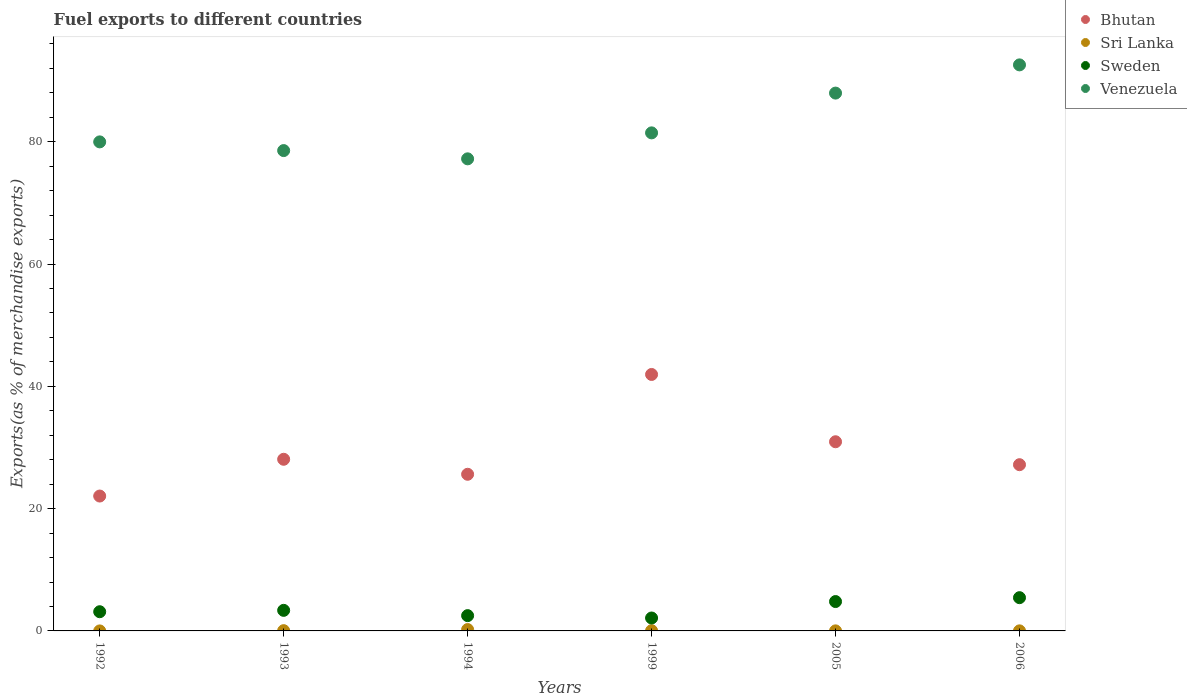Is the number of dotlines equal to the number of legend labels?
Offer a terse response. Yes. What is the percentage of exports to different countries in Sri Lanka in 1992?
Make the answer very short. 0. Across all years, what is the maximum percentage of exports to different countries in Venezuela?
Keep it short and to the point. 92.57. Across all years, what is the minimum percentage of exports to different countries in Sweden?
Your answer should be compact. 2.11. In which year was the percentage of exports to different countries in Sweden maximum?
Offer a very short reply. 2006. What is the total percentage of exports to different countries in Sweden in the graph?
Your answer should be compact. 21.36. What is the difference between the percentage of exports to different countries in Sri Lanka in 1992 and that in 2006?
Make the answer very short. -0.01. What is the difference between the percentage of exports to different countries in Sweden in 1993 and the percentage of exports to different countries in Venezuela in 2006?
Offer a very short reply. -89.21. What is the average percentage of exports to different countries in Bhutan per year?
Offer a terse response. 29.3. In the year 1992, what is the difference between the percentage of exports to different countries in Bhutan and percentage of exports to different countries in Sri Lanka?
Provide a short and direct response. 22.06. What is the ratio of the percentage of exports to different countries in Sweden in 1993 to that in 1994?
Offer a terse response. 1.35. Is the percentage of exports to different countries in Sweden in 1993 less than that in 2006?
Offer a terse response. Yes. What is the difference between the highest and the second highest percentage of exports to different countries in Sri Lanka?
Ensure brevity in your answer.  0.18. What is the difference between the highest and the lowest percentage of exports to different countries in Sri Lanka?
Your answer should be very brief. 0.22. Is the sum of the percentage of exports to different countries in Venezuela in 1992 and 2006 greater than the maximum percentage of exports to different countries in Bhutan across all years?
Offer a terse response. Yes. Is it the case that in every year, the sum of the percentage of exports to different countries in Bhutan and percentage of exports to different countries in Sri Lanka  is greater than the sum of percentage of exports to different countries in Sweden and percentage of exports to different countries in Venezuela?
Offer a very short reply. Yes. Does the percentage of exports to different countries in Sri Lanka monotonically increase over the years?
Ensure brevity in your answer.  No. How many dotlines are there?
Keep it short and to the point. 4. How many years are there in the graph?
Keep it short and to the point. 6. Are the values on the major ticks of Y-axis written in scientific E-notation?
Your answer should be very brief. No. Does the graph contain any zero values?
Make the answer very short. No. Where does the legend appear in the graph?
Your answer should be compact. Top right. How many legend labels are there?
Keep it short and to the point. 4. How are the legend labels stacked?
Your answer should be very brief. Vertical. What is the title of the graph?
Give a very brief answer. Fuel exports to different countries. What is the label or title of the Y-axis?
Provide a short and direct response. Exports(as % of merchandise exports). What is the Exports(as % of merchandise exports) of Bhutan in 1992?
Your response must be concise. 22.06. What is the Exports(as % of merchandise exports) of Sri Lanka in 1992?
Make the answer very short. 0. What is the Exports(as % of merchandise exports) in Sweden in 1992?
Make the answer very short. 3.14. What is the Exports(as % of merchandise exports) in Venezuela in 1992?
Make the answer very short. 79.98. What is the Exports(as % of merchandise exports) of Bhutan in 1993?
Offer a very short reply. 28.07. What is the Exports(as % of merchandise exports) in Sri Lanka in 1993?
Make the answer very short. 0.04. What is the Exports(as % of merchandise exports) in Sweden in 1993?
Ensure brevity in your answer.  3.36. What is the Exports(as % of merchandise exports) of Venezuela in 1993?
Provide a succinct answer. 78.56. What is the Exports(as % of merchandise exports) of Bhutan in 1994?
Your answer should be very brief. 25.62. What is the Exports(as % of merchandise exports) of Sri Lanka in 1994?
Your answer should be very brief. 0.22. What is the Exports(as % of merchandise exports) in Sweden in 1994?
Your response must be concise. 2.5. What is the Exports(as % of merchandise exports) of Venezuela in 1994?
Ensure brevity in your answer.  77.21. What is the Exports(as % of merchandise exports) in Bhutan in 1999?
Your response must be concise. 41.94. What is the Exports(as % of merchandise exports) in Sri Lanka in 1999?
Make the answer very short. 0.04. What is the Exports(as % of merchandise exports) of Sweden in 1999?
Your response must be concise. 2.11. What is the Exports(as % of merchandise exports) in Venezuela in 1999?
Give a very brief answer. 81.45. What is the Exports(as % of merchandise exports) of Bhutan in 2005?
Provide a succinct answer. 30.94. What is the Exports(as % of merchandise exports) in Sri Lanka in 2005?
Keep it short and to the point. 0.01. What is the Exports(as % of merchandise exports) in Sweden in 2005?
Ensure brevity in your answer.  4.8. What is the Exports(as % of merchandise exports) of Venezuela in 2005?
Provide a short and direct response. 87.96. What is the Exports(as % of merchandise exports) of Bhutan in 2006?
Give a very brief answer. 27.19. What is the Exports(as % of merchandise exports) of Sri Lanka in 2006?
Give a very brief answer. 0.01. What is the Exports(as % of merchandise exports) of Sweden in 2006?
Provide a succinct answer. 5.44. What is the Exports(as % of merchandise exports) of Venezuela in 2006?
Your answer should be compact. 92.57. Across all years, what is the maximum Exports(as % of merchandise exports) of Bhutan?
Your response must be concise. 41.94. Across all years, what is the maximum Exports(as % of merchandise exports) in Sri Lanka?
Give a very brief answer. 0.22. Across all years, what is the maximum Exports(as % of merchandise exports) in Sweden?
Your answer should be compact. 5.44. Across all years, what is the maximum Exports(as % of merchandise exports) in Venezuela?
Provide a succinct answer. 92.57. Across all years, what is the minimum Exports(as % of merchandise exports) in Bhutan?
Offer a very short reply. 22.06. Across all years, what is the minimum Exports(as % of merchandise exports) in Sri Lanka?
Give a very brief answer. 0. Across all years, what is the minimum Exports(as % of merchandise exports) in Sweden?
Offer a very short reply. 2.11. Across all years, what is the minimum Exports(as % of merchandise exports) of Venezuela?
Provide a short and direct response. 77.21. What is the total Exports(as % of merchandise exports) in Bhutan in the graph?
Keep it short and to the point. 175.81. What is the total Exports(as % of merchandise exports) in Sri Lanka in the graph?
Your response must be concise. 0.32. What is the total Exports(as % of merchandise exports) of Sweden in the graph?
Give a very brief answer. 21.36. What is the total Exports(as % of merchandise exports) of Venezuela in the graph?
Your answer should be compact. 497.73. What is the difference between the Exports(as % of merchandise exports) of Bhutan in 1992 and that in 1993?
Provide a succinct answer. -6.01. What is the difference between the Exports(as % of merchandise exports) in Sri Lanka in 1992 and that in 1993?
Keep it short and to the point. -0.04. What is the difference between the Exports(as % of merchandise exports) of Sweden in 1992 and that in 1993?
Offer a terse response. -0.22. What is the difference between the Exports(as % of merchandise exports) in Venezuela in 1992 and that in 1993?
Your answer should be compact. 1.42. What is the difference between the Exports(as % of merchandise exports) in Bhutan in 1992 and that in 1994?
Give a very brief answer. -3.56. What is the difference between the Exports(as % of merchandise exports) of Sri Lanka in 1992 and that in 1994?
Offer a very short reply. -0.22. What is the difference between the Exports(as % of merchandise exports) of Sweden in 1992 and that in 1994?
Offer a terse response. 0.64. What is the difference between the Exports(as % of merchandise exports) in Venezuela in 1992 and that in 1994?
Provide a short and direct response. 2.77. What is the difference between the Exports(as % of merchandise exports) of Bhutan in 1992 and that in 1999?
Ensure brevity in your answer.  -19.88. What is the difference between the Exports(as % of merchandise exports) in Sri Lanka in 1992 and that in 1999?
Offer a terse response. -0.04. What is the difference between the Exports(as % of merchandise exports) of Sweden in 1992 and that in 1999?
Your answer should be compact. 1.03. What is the difference between the Exports(as % of merchandise exports) in Venezuela in 1992 and that in 1999?
Your answer should be compact. -1.47. What is the difference between the Exports(as % of merchandise exports) in Bhutan in 1992 and that in 2005?
Keep it short and to the point. -8.88. What is the difference between the Exports(as % of merchandise exports) of Sri Lanka in 1992 and that in 2005?
Your response must be concise. -0.01. What is the difference between the Exports(as % of merchandise exports) in Sweden in 1992 and that in 2005?
Offer a very short reply. -1.66. What is the difference between the Exports(as % of merchandise exports) of Venezuela in 1992 and that in 2005?
Your response must be concise. -7.98. What is the difference between the Exports(as % of merchandise exports) in Bhutan in 1992 and that in 2006?
Your answer should be very brief. -5.13. What is the difference between the Exports(as % of merchandise exports) of Sri Lanka in 1992 and that in 2006?
Your response must be concise. -0.01. What is the difference between the Exports(as % of merchandise exports) of Sweden in 1992 and that in 2006?
Provide a succinct answer. -2.3. What is the difference between the Exports(as % of merchandise exports) of Venezuela in 1992 and that in 2006?
Keep it short and to the point. -12.59. What is the difference between the Exports(as % of merchandise exports) of Bhutan in 1993 and that in 1994?
Your answer should be compact. 2.45. What is the difference between the Exports(as % of merchandise exports) of Sri Lanka in 1993 and that in 1994?
Keep it short and to the point. -0.18. What is the difference between the Exports(as % of merchandise exports) in Sweden in 1993 and that in 1994?
Offer a terse response. 0.86. What is the difference between the Exports(as % of merchandise exports) of Venezuela in 1993 and that in 1994?
Make the answer very short. 1.35. What is the difference between the Exports(as % of merchandise exports) in Bhutan in 1993 and that in 1999?
Give a very brief answer. -13.87. What is the difference between the Exports(as % of merchandise exports) in Sri Lanka in 1993 and that in 1999?
Offer a very short reply. 0. What is the difference between the Exports(as % of merchandise exports) in Sweden in 1993 and that in 1999?
Your answer should be compact. 1.25. What is the difference between the Exports(as % of merchandise exports) of Venezuela in 1993 and that in 1999?
Ensure brevity in your answer.  -2.9. What is the difference between the Exports(as % of merchandise exports) in Bhutan in 1993 and that in 2005?
Your response must be concise. -2.87. What is the difference between the Exports(as % of merchandise exports) of Sri Lanka in 1993 and that in 2005?
Your answer should be very brief. 0.03. What is the difference between the Exports(as % of merchandise exports) in Sweden in 1993 and that in 2005?
Make the answer very short. -1.44. What is the difference between the Exports(as % of merchandise exports) of Venezuela in 1993 and that in 2005?
Offer a terse response. -9.4. What is the difference between the Exports(as % of merchandise exports) of Bhutan in 1993 and that in 2006?
Keep it short and to the point. 0.89. What is the difference between the Exports(as % of merchandise exports) in Sri Lanka in 1993 and that in 2006?
Make the answer very short. 0.03. What is the difference between the Exports(as % of merchandise exports) in Sweden in 1993 and that in 2006?
Provide a short and direct response. -2.07. What is the difference between the Exports(as % of merchandise exports) in Venezuela in 1993 and that in 2006?
Keep it short and to the point. -14.02. What is the difference between the Exports(as % of merchandise exports) of Bhutan in 1994 and that in 1999?
Give a very brief answer. -16.32. What is the difference between the Exports(as % of merchandise exports) in Sri Lanka in 1994 and that in 1999?
Offer a terse response. 0.18. What is the difference between the Exports(as % of merchandise exports) of Sweden in 1994 and that in 1999?
Your response must be concise. 0.39. What is the difference between the Exports(as % of merchandise exports) in Venezuela in 1994 and that in 1999?
Offer a very short reply. -4.25. What is the difference between the Exports(as % of merchandise exports) of Bhutan in 1994 and that in 2005?
Your answer should be very brief. -5.32. What is the difference between the Exports(as % of merchandise exports) of Sri Lanka in 1994 and that in 2005?
Your answer should be compact. 0.21. What is the difference between the Exports(as % of merchandise exports) in Sweden in 1994 and that in 2005?
Ensure brevity in your answer.  -2.3. What is the difference between the Exports(as % of merchandise exports) of Venezuela in 1994 and that in 2005?
Keep it short and to the point. -10.75. What is the difference between the Exports(as % of merchandise exports) of Bhutan in 1994 and that in 2006?
Ensure brevity in your answer.  -1.57. What is the difference between the Exports(as % of merchandise exports) of Sri Lanka in 1994 and that in 2006?
Your answer should be very brief. 0.21. What is the difference between the Exports(as % of merchandise exports) of Sweden in 1994 and that in 2006?
Ensure brevity in your answer.  -2.94. What is the difference between the Exports(as % of merchandise exports) in Venezuela in 1994 and that in 2006?
Offer a terse response. -15.37. What is the difference between the Exports(as % of merchandise exports) in Bhutan in 1999 and that in 2005?
Offer a terse response. 11. What is the difference between the Exports(as % of merchandise exports) of Sri Lanka in 1999 and that in 2005?
Your answer should be very brief. 0.03. What is the difference between the Exports(as % of merchandise exports) of Sweden in 1999 and that in 2005?
Give a very brief answer. -2.69. What is the difference between the Exports(as % of merchandise exports) in Venezuela in 1999 and that in 2005?
Your answer should be compact. -6.5. What is the difference between the Exports(as % of merchandise exports) in Bhutan in 1999 and that in 2006?
Your response must be concise. 14.76. What is the difference between the Exports(as % of merchandise exports) of Sri Lanka in 1999 and that in 2006?
Your answer should be very brief. 0.03. What is the difference between the Exports(as % of merchandise exports) of Sweden in 1999 and that in 2006?
Ensure brevity in your answer.  -3.33. What is the difference between the Exports(as % of merchandise exports) in Venezuela in 1999 and that in 2006?
Your response must be concise. -11.12. What is the difference between the Exports(as % of merchandise exports) in Bhutan in 2005 and that in 2006?
Provide a succinct answer. 3.75. What is the difference between the Exports(as % of merchandise exports) in Sri Lanka in 2005 and that in 2006?
Offer a very short reply. -0. What is the difference between the Exports(as % of merchandise exports) of Sweden in 2005 and that in 2006?
Provide a short and direct response. -0.63. What is the difference between the Exports(as % of merchandise exports) of Venezuela in 2005 and that in 2006?
Ensure brevity in your answer.  -4.62. What is the difference between the Exports(as % of merchandise exports) of Bhutan in 1992 and the Exports(as % of merchandise exports) of Sri Lanka in 1993?
Keep it short and to the point. 22.02. What is the difference between the Exports(as % of merchandise exports) of Bhutan in 1992 and the Exports(as % of merchandise exports) of Sweden in 1993?
Provide a short and direct response. 18.7. What is the difference between the Exports(as % of merchandise exports) in Bhutan in 1992 and the Exports(as % of merchandise exports) in Venezuela in 1993?
Your answer should be compact. -56.5. What is the difference between the Exports(as % of merchandise exports) in Sri Lanka in 1992 and the Exports(as % of merchandise exports) in Sweden in 1993?
Give a very brief answer. -3.36. What is the difference between the Exports(as % of merchandise exports) in Sri Lanka in 1992 and the Exports(as % of merchandise exports) in Venezuela in 1993?
Make the answer very short. -78.56. What is the difference between the Exports(as % of merchandise exports) in Sweden in 1992 and the Exports(as % of merchandise exports) in Venezuela in 1993?
Offer a very short reply. -75.42. What is the difference between the Exports(as % of merchandise exports) in Bhutan in 1992 and the Exports(as % of merchandise exports) in Sri Lanka in 1994?
Your response must be concise. 21.84. What is the difference between the Exports(as % of merchandise exports) in Bhutan in 1992 and the Exports(as % of merchandise exports) in Sweden in 1994?
Provide a succinct answer. 19.56. What is the difference between the Exports(as % of merchandise exports) of Bhutan in 1992 and the Exports(as % of merchandise exports) of Venezuela in 1994?
Offer a terse response. -55.15. What is the difference between the Exports(as % of merchandise exports) in Sri Lanka in 1992 and the Exports(as % of merchandise exports) in Sweden in 1994?
Your answer should be compact. -2.5. What is the difference between the Exports(as % of merchandise exports) in Sri Lanka in 1992 and the Exports(as % of merchandise exports) in Venezuela in 1994?
Provide a short and direct response. -77.21. What is the difference between the Exports(as % of merchandise exports) of Sweden in 1992 and the Exports(as % of merchandise exports) of Venezuela in 1994?
Your response must be concise. -74.07. What is the difference between the Exports(as % of merchandise exports) of Bhutan in 1992 and the Exports(as % of merchandise exports) of Sri Lanka in 1999?
Offer a terse response. 22.02. What is the difference between the Exports(as % of merchandise exports) in Bhutan in 1992 and the Exports(as % of merchandise exports) in Sweden in 1999?
Give a very brief answer. 19.95. What is the difference between the Exports(as % of merchandise exports) in Bhutan in 1992 and the Exports(as % of merchandise exports) in Venezuela in 1999?
Provide a short and direct response. -59.39. What is the difference between the Exports(as % of merchandise exports) of Sri Lanka in 1992 and the Exports(as % of merchandise exports) of Sweden in 1999?
Provide a succinct answer. -2.11. What is the difference between the Exports(as % of merchandise exports) in Sri Lanka in 1992 and the Exports(as % of merchandise exports) in Venezuela in 1999?
Make the answer very short. -81.45. What is the difference between the Exports(as % of merchandise exports) of Sweden in 1992 and the Exports(as % of merchandise exports) of Venezuela in 1999?
Provide a succinct answer. -78.31. What is the difference between the Exports(as % of merchandise exports) in Bhutan in 1992 and the Exports(as % of merchandise exports) in Sri Lanka in 2005?
Your response must be concise. 22.05. What is the difference between the Exports(as % of merchandise exports) of Bhutan in 1992 and the Exports(as % of merchandise exports) of Sweden in 2005?
Give a very brief answer. 17.26. What is the difference between the Exports(as % of merchandise exports) of Bhutan in 1992 and the Exports(as % of merchandise exports) of Venezuela in 2005?
Provide a short and direct response. -65.9. What is the difference between the Exports(as % of merchandise exports) of Sri Lanka in 1992 and the Exports(as % of merchandise exports) of Sweden in 2005?
Give a very brief answer. -4.8. What is the difference between the Exports(as % of merchandise exports) of Sri Lanka in 1992 and the Exports(as % of merchandise exports) of Venezuela in 2005?
Ensure brevity in your answer.  -87.96. What is the difference between the Exports(as % of merchandise exports) in Sweden in 1992 and the Exports(as % of merchandise exports) in Venezuela in 2005?
Offer a terse response. -84.82. What is the difference between the Exports(as % of merchandise exports) in Bhutan in 1992 and the Exports(as % of merchandise exports) in Sri Lanka in 2006?
Your answer should be very brief. 22.05. What is the difference between the Exports(as % of merchandise exports) in Bhutan in 1992 and the Exports(as % of merchandise exports) in Sweden in 2006?
Ensure brevity in your answer.  16.62. What is the difference between the Exports(as % of merchandise exports) of Bhutan in 1992 and the Exports(as % of merchandise exports) of Venezuela in 2006?
Provide a succinct answer. -70.51. What is the difference between the Exports(as % of merchandise exports) in Sri Lanka in 1992 and the Exports(as % of merchandise exports) in Sweden in 2006?
Provide a succinct answer. -5.44. What is the difference between the Exports(as % of merchandise exports) of Sri Lanka in 1992 and the Exports(as % of merchandise exports) of Venezuela in 2006?
Keep it short and to the point. -92.57. What is the difference between the Exports(as % of merchandise exports) in Sweden in 1992 and the Exports(as % of merchandise exports) in Venezuela in 2006?
Make the answer very short. -89.43. What is the difference between the Exports(as % of merchandise exports) in Bhutan in 1993 and the Exports(as % of merchandise exports) in Sri Lanka in 1994?
Your answer should be very brief. 27.85. What is the difference between the Exports(as % of merchandise exports) of Bhutan in 1993 and the Exports(as % of merchandise exports) of Sweden in 1994?
Offer a terse response. 25.57. What is the difference between the Exports(as % of merchandise exports) of Bhutan in 1993 and the Exports(as % of merchandise exports) of Venezuela in 1994?
Your answer should be compact. -49.14. What is the difference between the Exports(as % of merchandise exports) of Sri Lanka in 1993 and the Exports(as % of merchandise exports) of Sweden in 1994?
Provide a succinct answer. -2.46. What is the difference between the Exports(as % of merchandise exports) of Sri Lanka in 1993 and the Exports(as % of merchandise exports) of Venezuela in 1994?
Provide a succinct answer. -77.16. What is the difference between the Exports(as % of merchandise exports) of Sweden in 1993 and the Exports(as % of merchandise exports) of Venezuela in 1994?
Give a very brief answer. -73.84. What is the difference between the Exports(as % of merchandise exports) of Bhutan in 1993 and the Exports(as % of merchandise exports) of Sri Lanka in 1999?
Provide a succinct answer. 28.03. What is the difference between the Exports(as % of merchandise exports) of Bhutan in 1993 and the Exports(as % of merchandise exports) of Sweden in 1999?
Make the answer very short. 25.96. What is the difference between the Exports(as % of merchandise exports) of Bhutan in 1993 and the Exports(as % of merchandise exports) of Venezuela in 1999?
Provide a short and direct response. -53.38. What is the difference between the Exports(as % of merchandise exports) of Sri Lanka in 1993 and the Exports(as % of merchandise exports) of Sweden in 1999?
Provide a succinct answer. -2.07. What is the difference between the Exports(as % of merchandise exports) of Sri Lanka in 1993 and the Exports(as % of merchandise exports) of Venezuela in 1999?
Your answer should be compact. -81.41. What is the difference between the Exports(as % of merchandise exports) of Sweden in 1993 and the Exports(as % of merchandise exports) of Venezuela in 1999?
Make the answer very short. -78.09. What is the difference between the Exports(as % of merchandise exports) in Bhutan in 1993 and the Exports(as % of merchandise exports) in Sri Lanka in 2005?
Make the answer very short. 28.06. What is the difference between the Exports(as % of merchandise exports) of Bhutan in 1993 and the Exports(as % of merchandise exports) of Sweden in 2005?
Your answer should be very brief. 23.27. What is the difference between the Exports(as % of merchandise exports) of Bhutan in 1993 and the Exports(as % of merchandise exports) of Venezuela in 2005?
Ensure brevity in your answer.  -59.89. What is the difference between the Exports(as % of merchandise exports) of Sri Lanka in 1993 and the Exports(as % of merchandise exports) of Sweden in 2005?
Offer a terse response. -4.76. What is the difference between the Exports(as % of merchandise exports) in Sri Lanka in 1993 and the Exports(as % of merchandise exports) in Venezuela in 2005?
Make the answer very short. -87.92. What is the difference between the Exports(as % of merchandise exports) in Sweden in 1993 and the Exports(as % of merchandise exports) in Venezuela in 2005?
Offer a very short reply. -84.59. What is the difference between the Exports(as % of merchandise exports) of Bhutan in 1993 and the Exports(as % of merchandise exports) of Sri Lanka in 2006?
Offer a very short reply. 28.06. What is the difference between the Exports(as % of merchandise exports) in Bhutan in 1993 and the Exports(as % of merchandise exports) in Sweden in 2006?
Give a very brief answer. 22.63. What is the difference between the Exports(as % of merchandise exports) of Bhutan in 1993 and the Exports(as % of merchandise exports) of Venezuela in 2006?
Your answer should be compact. -64.5. What is the difference between the Exports(as % of merchandise exports) in Sri Lanka in 1993 and the Exports(as % of merchandise exports) in Sweden in 2006?
Your answer should be very brief. -5.4. What is the difference between the Exports(as % of merchandise exports) in Sri Lanka in 1993 and the Exports(as % of merchandise exports) in Venezuela in 2006?
Keep it short and to the point. -92.53. What is the difference between the Exports(as % of merchandise exports) in Sweden in 1993 and the Exports(as % of merchandise exports) in Venezuela in 2006?
Offer a terse response. -89.21. What is the difference between the Exports(as % of merchandise exports) of Bhutan in 1994 and the Exports(as % of merchandise exports) of Sri Lanka in 1999?
Provide a succinct answer. 25.58. What is the difference between the Exports(as % of merchandise exports) in Bhutan in 1994 and the Exports(as % of merchandise exports) in Sweden in 1999?
Your answer should be compact. 23.51. What is the difference between the Exports(as % of merchandise exports) in Bhutan in 1994 and the Exports(as % of merchandise exports) in Venezuela in 1999?
Keep it short and to the point. -55.84. What is the difference between the Exports(as % of merchandise exports) of Sri Lanka in 1994 and the Exports(as % of merchandise exports) of Sweden in 1999?
Your answer should be very brief. -1.89. What is the difference between the Exports(as % of merchandise exports) of Sri Lanka in 1994 and the Exports(as % of merchandise exports) of Venezuela in 1999?
Keep it short and to the point. -81.23. What is the difference between the Exports(as % of merchandise exports) in Sweden in 1994 and the Exports(as % of merchandise exports) in Venezuela in 1999?
Your answer should be compact. -78.95. What is the difference between the Exports(as % of merchandise exports) of Bhutan in 1994 and the Exports(as % of merchandise exports) of Sri Lanka in 2005?
Offer a very short reply. 25.61. What is the difference between the Exports(as % of merchandise exports) of Bhutan in 1994 and the Exports(as % of merchandise exports) of Sweden in 2005?
Give a very brief answer. 20.81. What is the difference between the Exports(as % of merchandise exports) of Bhutan in 1994 and the Exports(as % of merchandise exports) of Venezuela in 2005?
Offer a very short reply. -62.34. What is the difference between the Exports(as % of merchandise exports) of Sri Lanka in 1994 and the Exports(as % of merchandise exports) of Sweden in 2005?
Provide a succinct answer. -4.58. What is the difference between the Exports(as % of merchandise exports) of Sri Lanka in 1994 and the Exports(as % of merchandise exports) of Venezuela in 2005?
Keep it short and to the point. -87.73. What is the difference between the Exports(as % of merchandise exports) in Sweden in 1994 and the Exports(as % of merchandise exports) in Venezuela in 2005?
Your answer should be compact. -85.46. What is the difference between the Exports(as % of merchandise exports) in Bhutan in 1994 and the Exports(as % of merchandise exports) in Sri Lanka in 2006?
Ensure brevity in your answer.  25.61. What is the difference between the Exports(as % of merchandise exports) in Bhutan in 1994 and the Exports(as % of merchandise exports) in Sweden in 2006?
Offer a terse response. 20.18. What is the difference between the Exports(as % of merchandise exports) in Bhutan in 1994 and the Exports(as % of merchandise exports) in Venezuela in 2006?
Offer a terse response. -66.95. What is the difference between the Exports(as % of merchandise exports) in Sri Lanka in 1994 and the Exports(as % of merchandise exports) in Sweden in 2006?
Offer a terse response. -5.21. What is the difference between the Exports(as % of merchandise exports) in Sri Lanka in 1994 and the Exports(as % of merchandise exports) in Venezuela in 2006?
Your answer should be very brief. -92.35. What is the difference between the Exports(as % of merchandise exports) in Sweden in 1994 and the Exports(as % of merchandise exports) in Venezuela in 2006?
Make the answer very short. -90.07. What is the difference between the Exports(as % of merchandise exports) of Bhutan in 1999 and the Exports(as % of merchandise exports) of Sri Lanka in 2005?
Give a very brief answer. 41.93. What is the difference between the Exports(as % of merchandise exports) of Bhutan in 1999 and the Exports(as % of merchandise exports) of Sweden in 2005?
Your answer should be very brief. 37.14. What is the difference between the Exports(as % of merchandise exports) in Bhutan in 1999 and the Exports(as % of merchandise exports) in Venezuela in 2005?
Your answer should be very brief. -46.02. What is the difference between the Exports(as % of merchandise exports) in Sri Lanka in 1999 and the Exports(as % of merchandise exports) in Sweden in 2005?
Keep it short and to the point. -4.76. What is the difference between the Exports(as % of merchandise exports) of Sri Lanka in 1999 and the Exports(as % of merchandise exports) of Venezuela in 2005?
Offer a terse response. -87.92. What is the difference between the Exports(as % of merchandise exports) in Sweden in 1999 and the Exports(as % of merchandise exports) in Venezuela in 2005?
Keep it short and to the point. -85.85. What is the difference between the Exports(as % of merchandise exports) of Bhutan in 1999 and the Exports(as % of merchandise exports) of Sri Lanka in 2006?
Offer a terse response. 41.93. What is the difference between the Exports(as % of merchandise exports) of Bhutan in 1999 and the Exports(as % of merchandise exports) of Sweden in 2006?
Keep it short and to the point. 36.5. What is the difference between the Exports(as % of merchandise exports) in Bhutan in 1999 and the Exports(as % of merchandise exports) in Venezuela in 2006?
Offer a very short reply. -50.63. What is the difference between the Exports(as % of merchandise exports) in Sri Lanka in 1999 and the Exports(as % of merchandise exports) in Sweden in 2006?
Ensure brevity in your answer.  -5.4. What is the difference between the Exports(as % of merchandise exports) of Sri Lanka in 1999 and the Exports(as % of merchandise exports) of Venezuela in 2006?
Offer a very short reply. -92.53. What is the difference between the Exports(as % of merchandise exports) in Sweden in 1999 and the Exports(as % of merchandise exports) in Venezuela in 2006?
Your answer should be very brief. -90.46. What is the difference between the Exports(as % of merchandise exports) of Bhutan in 2005 and the Exports(as % of merchandise exports) of Sri Lanka in 2006?
Provide a succinct answer. 30.93. What is the difference between the Exports(as % of merchandise exports) in Bhutan in 2005 and the Exports(as % of merchandise exports) in Sweden in 2006?
Your answer should be very brief. 25.5. What is the difference between the Exports(as % of merchandise exports) in Bhutan in 2005 and the Exports(as % of merchandise exports) in Venezuela in 2006?
Keep it short and to the point. -61.64. What is the difference between the Exports(as % of merchandise exports) in Sri Lanka in 2005 and the Exports(as % of merchandise exports) in Sweden in 2006?
Your answer should be compact. -5.43. What is the difference between the Exports(as % of merchandise exports) in Sri Lanka in 2005 and the Exports(as % of merchandise exports) in Venezuela in 2006?
Provide a succinct answer. -92.56. What is the difference between the Exports(as % of merchandise exports) of Sweden in 2005 and the Exports(as % of merchandise exports) of Venezuela in 2006?
Provide a short and direct response. -87.77. What is the average Exports(as % of merchandise exports) of Bhutan per year?
Offer a terse response. 29.3. What is the average Exports(as % of merchandise exports) in Sri Lanka per year?
Give a very brief answer. 0.05. What is the average Exports(as % of merchandise exports) in Sweden per year?
Provide a succinct answer. 3.56. What is the average Exports(as % of merchandise exports) of Venezuela per year?
Offer a terse response. 82.95. In the year 1992, what is the difference between the Exports(as % of merchandise exports) of Bhutan and Exports(as % of merchandise exports) of Sri Lanka?
Make the answer very short. 22.06. In the year 1992, what is the difference between the Exports(as % of merchandise exports) of Bhutan and Exports(as % of merchandise exports) of Sweden?
Ensure brevity in your answer.  18.92. In the year 1992, what is the difference between the Exports(as % of merchandise exports) in Bhutan and Exports(as % of merchandise exports) in Venezuela?
Keep it short and to the point. -57.92. In the year 1992, what is the difference between the Exports(as % of merchandise exports) in Sri Lanka and Exports(as % of merchandise exports) in Sweden?
Make the answer very short. -3.14. In the year 1992, what is the difference between the Exports(as % of merchandise exports) of Sri Lanka and Exports(as % of merchandise exports) of Venezuela?
Offer a terse response. -79.98. In the year 1992, what is the difference between the Exports(as % of merchandise exports) in Sweden and Exports(as % of merchandise exports) in Venezuela?
Your answer should be very brief. -76.84. In the year 1993, what is the difference between the Exports(as % of merchandise exports) in Bhutan and Exports(as % of merchandise exports) in Sri Lanka?
Provide a succinct answer. 28.03. In the year 1993, what is the difference between the Exports(as % of merchandise exports) of Bhutan and Exports(as % of merchandise exports) of Sweden?
Keep it short and to the point. 24.71. In the year 1993, what is the difference between the Exports(as % of merchandise exports) in Bhutan and Exports(as % of merchandise exports) in Venezuela?
Ensure brevity in your answer.  -50.49. In the year 1993, what is the difference between the Exports(as % of merchandise exports) in Sri Lanka and Exports(as % of merchandise exports) in Sweden?
Provide a succinct answer. -3.32. In the year 1993, what is the difference between the Exports(as % of merchandise exports) of Sri Lanka and Exports(as % of merchandise exports) of Venezuela?
Offer a very short reply. -78.51. In the year 1993, what is the difference between the Exports(as % of merchandise exports) of Sweden and Exports(as % of merchandise exports) of Venezuela?
Keep it short and to the point. -75.19. In the year 1994, what is the difference between the Exports(as % of merchandise exports) of Bhutan and Exports(as % of merchandise exports) of Sri Lanka?
Provide a short and direct response. 25.4. In the year 1994, what is the difference between the Exports(as % of merchandise exports) of Bhutan and Exports(as % of merchandise exports) of Sweden?
Provide a succinct answer. 23.12. In the year 1994, what is the difference between the Exports(as % of merchandise exports) of Bhutan and Exports(as % of merchandise exports) of Venezuela?
Keep it short and to the point. -51.59. In the year 1994, what is the difference between the Exports(as % of merchandise exports) of Sri Lanka and Exports(as % of merchandise exports) of Sweden?
Offer a very short reply. -2.28. In the year 1994, what is the difference between the Exports(as % of merchandise exports) in Sri Lanka and Exports(as % of merchandise exports) in Venezuela?
Offer a terse response. -76.98. In the year 1994, what is the difference between the Exports(as % of merchandise exports) of Sweden and Exports(as % of merchandise exports) of Venezuela?
Offer a very short reply. -74.71. In the year 1999, what is the difference between the Exports(as % of merchandise exports) in Bhutan and Exports(as % of merchandise exports) in Sri Lanka?
Provide a short and direct response. 41.9. In the year 1999, what is the difference between the Exports(as % of merchandise exports) in Bhutan and Exports(as % of merchandise exports) in Sweden?
Your answer should be compact. 39.83. In the year 1999, what is the difference between the Exports(as % of merchandise exports) in Bhutan and Exports(as % of merchandise exports) in Venezuela?
Your response must be concise. -39.51. In the year 1999, what is the difference between the Exports(as % of merchandise exports) of Sri Lanka and Exports(as % of merchandise exports) of Sweden?
Offer a very short reply. -2.07. In the year 1999, what is the difference between the Exports(as % of merchandise exports) in Sri Lanka and Exports(as % of merchandise exports) in Venezuela?
Ensure brevity in your answer.  -81.41. In the year 1999, what is the difference between the Exports(as % of merchandise exports) of Sweden and Exports(as % of merchandise exports) of Venezuela?
Make the answer very short. -79.34. In the year 2005, what is the difference between the Exports(as % of merchandise exports) of Bhutan and Exports(as % of merchandise exports) of Sri Lanka?
Ensure brevity in your answer.  30.93. In the year 2005, what is the difference between the Exports(as % of merchandise exports) of Bhutan and Exports(as % of merchandise exports) of Sweden?
Offer a very short reply. 26.13. In the year 2005, what is the difference between the Exports(as % of merchandise exports) of Bhutan and Exports(as % of merchandise exports) of Venezuela?
Make the answer very short. -57.02. In the year 2005, what is the difference between the Exports(as % of merchandise exports) in Sri Lanka and Exports(as % of merchandise exports) in Sweden?
Your answer should be compact. -4.8. In the year 2005, what is the difference between the Exports(as % of merchandise exports) of Sri Lanka and Exports(as % of merchandise exports) of Venezuela?
Provide a short and direct response. -87.95. In the year 2005, what is the difference between the Exports(as % of merchandise exports) in Sweden and Exports(as % of merchandise exports) in Venezuela?
Your answer should be very brief. -83.15. In the year 2006, what is the difference between the Exports(as % of merchandise exports) in Bhutan and Exports(as % of merchandise exports) in Sri Lanka?
Make the answer very short. 27.18. In the year 2006, what is the difference between the Exports(as % of merchandise exports) of Bhutan and Exports(as % of merchandise exports) of Sweden?
Ensure brevity in your answer.  21.75. In the year 2006, what is the difference between the Exports(as % of merchandise exports) in Bhutan and Exports(as % of merchandise exports) in Venezuela?
Offer a terse response. -65.39. In the year 2006, what is the difference between the Exports(as % of merchandise exports) of Sri Lanka and Exports(as % of merchandise exports) of Sweden?
Your answer should be very brief. -5.43. In the year 2006, what is the difference between the Exports(as % of merchandise exports) of Sri Lanka and Exports(as % of merchandise exports) of Venezuela?
Your response must be concise. -92.56. In the year 2006, what is the difference between the Exports(as % of merchandise exports) in Sweden and Exports(as % of merchandise exports) in Venezuela?
Provide a short and direct response. -87.14. What is the ratio of the Exports(as % of merchandise exports) of Bhutan in 1992 to that in 1993?
Make the answer very short. 0.79. What is the ratio of the Exports(as % of merchandise exports) in Sri Lanka in 1992 to that in 1993?
Your answer should be very brief. 0.01. What is the ratio of the Exports(as % of merchandise exports) in Sweden in 1992 to that in 1993?
Ensure brevity in your answer.  0.93. What is the ratio of the Exports(as % of merchandise exports) in Venezuela in 1992 to that in 1993?
Make the answer very short. 1.02. What is the ratio of the Exports(as % of merchandise exports) in Bhutan in 1992 to that in 1994?
Ensure brevity in your answer.  0.86. What is the ratio of the Exports(as % of merchandise exports) in Sri Lanka in 1992 to that in 1994?
Ensure brevity in your answer.  0. What is the ratio of the Exports(as % of merchandise exports) of Sweden in 1992 to that in 1994?
Make the answer very short. 1.26. What is the ratio of the Exports(as % of merchandise exports) of Venezuela in 1992 to that in 1994?
Your answer should be compact. 1.04. What is the ratio of the Exports(as % of merchandise exports) of Bhutan in 1992 to that in 1999?
Keep it short and to the point. 0.53. What is the ratio of the Exports(as % of merchandise exports) of Sri Lanka in 1992 to that in 1999?
Ensure brevity in your answer.  0.01. What is the ratio of the Exports(as % of merchandise exports) in Sweden in 1992 to that in 1999?
Your response must be concise. 1.49. What is the ratio of the Exports(as % of merchandise exports) in Venezuela in 1992 to that in 1999?
Offer a terse response. 0.98. What is the ratio of the Exports(as % of merchandise exports) in Bhutan in 1992 to that in 2005?
Make the answer very short. 0.71. What is the ratio of the Exports(as % of merchandise exports) in Sri Lanka in 1992 to that in 2005?
Provide a succinct answer. 0.06. What is the ratio of the Exports(as % of merchandise exports) in Sweden in 1992 to that in 2005?
Provide a short and direct response. 0.65. What is the ratio of the Exports(as % of merchandise exports) of Venezuela in 1992 to that in 2005?
Give a very brief answer. 0.91. What is the ratio of the Exports(as % of merchandise exports) of Bhutan in 1992 to that in 2006?
Your response must be concise. 0.81. What is the ratio of the Exports(as % of merchandise exports) in Sri Lanka in 1992 to that in 2006?
Your answer should be compact. 0.04. What is the ratio of the Exports(as % of merchandise exports) in Sweden in 1992 to that in 2006?
Provide a short and direct response. 0.58. What is the ratio of the Exports(as % of merchandise exports) in Venezuela in 1992 to that in 2006?
Keep it short and to the point. 0.86. What is the ratio of the Exports(as % of merchandise exports) of Bhutan in 1993 to that in 1994?
Offer a very short reply. 1.1. What is the ratio of the Exports(as % of merchandise exports) in Sri Lanka in 1993 to that in 1994?
Ensure brevity in your answer.  0.19. What is the ratio of the Exports(as % of merchandise exports) of Sweden in 1993 to that in 1994?
Make the answer very short. 1.35. What is the ratio of the Exports(as % of merchandise exports) of Venezuela in 1993 to that in 1994?
Make the answer very short. 1.02. What is the ratio of the Exports(as % of merchandise exports) of Bhutan in 1993 to that in 1999?
Give a very brief answer. 0.67. What is the ratio of the Exports(as % of merchandise exports) in Sri Lanka in 1993 to that in 1999?
Offer a terse response. 1.07. What is the ratio of the Exports(as % of merchandise exports) in Sweden in 1993 to that in 1999?
Keep it short and to the point. 1.59. What is the ratio of the Exports(as % of merchandise exports) of Venezuela in 1993 to that in 1999?
Your response must be concise. 0.96. What is the ratio of the Exports(as % of merchandise exports) of Bhutan in 1993 to that in 2005?
Your response must be concise. 0.91. What is the ratio of the Exports(as % of merchandise exports) of Sri Lanka in 1993 to that in 2005?
Provide a short and direct response. 4.88. What is the ratio of the Exports(as % of merchandise exports) in Sweden in 1993 to that in 2005?
Make the answer very short. 0.7. What is the ratio of the Exports(as % of merchandise exports) in Venezuela in 1993 to that in 2005?
Keep it short and to the point. 0.89. What is the ratio of the Exports(as % of merchandise exports) in Bhutan in 1993 to that in 2006?
Your answer should be compact. 1.03. What is the ratio of the Exports(as % of merchandise exports) of Sri Lanka in 1993 to that in 2006?
Your answer should be compact. 3.91. What is the ratio of the Exports(as % of merchandise exports) of Sweden in 1993 to that in 2006?
Offer a very short reply. 0.62. What is the ratio of the Exports(as % of merchandise exports) of Venezuela in 1993 to that in 2006?
Provide a succinct answer. 0.85. What is the ratio of the Exports(as % of merchandise exports) in Bhutan in 1994 to that in 1999?
Make the answer very short. 0.61. What is the ratio of the Exports(as % of merchandise exports) of Sri Lanka in 1994 to that in 1999?
Offer a terse response. 5.7. What is the ratio of the Exports(as % of merchandise exports) in Sweden in 1994 to that in 1999?
Offer a terse response. 1.18. What is the ratio of the Exports(as % of merchandise exports) in Venezuela in 1994 to that in 1999?
Offer a terse response. 0.95. What is the ratio of the Exports(as % of merchandise exports) of Bhutan in 1994 to that in 2005?
Your response must be concise. 0.83. What is the ratio of the Exports(as % of merchandise exports) in Sri Lanka in 1994 to that in 2005?
Offer a very short reply. 25.87. What is the ratio of the Exports(as % of merchandise exports) of Sweden in 1994 to that in 2005?
Give a very brief answer. 0.52. What is the ratio of the Exports(as % of merchandise exports) in Venezuela in 1994 to that in 2005?
Give a very brief answer. 0.88. What is the ratio of the Exports(as % of merchandise exports) of Bhutan in 1994 to that in 2006?
Offer a terse response. 0.94. What is the ratio of the Exports(as % of merchandise exports) of Sri Lanka in 1994 to that in 2006?
Keep it short and to the point. 20.71. What is the ratio of the Exports(as % of merchandise exports) in Sweden in 1994 to that in 2006?
Your answer should be compact. 0.46. What is the ratio of the Exports(as % of merchandise exports) in Venezuela in 1994 to that in 2006?
Offer a terse response. 0.83. What is the ratio of the Exports(as % of merchandise exports) in Bhutan in 1999 to that in 2005?
Give a very brief answer. 1.36. What is the ratio of the Exports(as % of merchandise exports) in Sri Lanka in 1999 to that in 2005?
Your answer should be compact. 4.54. What is the ratio of the Exports(as % of merchandise exports) in Sweden in 1999 to that in 2005?
Make the answer very short. 0.44. What is the ratio of the Exports(as % of merchandise exports) in Venezuela in 1999 to that in 2005?
Your answer should be very brief. 0.93. What is the ratio of the Exports(as % of merchandise exports) in Bhutan in 1999 to that in 2006?
Provide a succinct answer. 1.54. What is the ratio of the Exports(as % of merchandise exports) in Sri Lanka in 1999 to that in 2006?
Your response must be concise. 3.64. What is the ratio of the Exports(as % of merchandise exports) in Sweden in 1999 to that in 2006?
Provide a succinct answer. 0.39. What is the ratio of the Exports(as % of merchandise exports) in Venezuela in 1999 to that in 2006?
Give a very brief answer. 0.88. What is the ratio of the Exports(as % of merchandise exports) of Bhutan in 2005 to that in 2006?
Keep it short and to the point. 1.14. What is the ratio of the Exports(as % of merchandise exports) in Sri Lanka in 2005 to that in 2006?
Ensure brevity in your answer.  0.8. What is the ratio of the Exports(as % of merchandise exports) of Sweden in 2005 to that in 2006?
Provide a succinct answer. 0.88. What is the ratio of the Exports(as % of merchandise exports) of Venezuela in 2005 to that in 2006?
Your response must be concise. 0.95. What is the difference between the highest and the second highest Exports(as % of merchandise exports) of Bhutan?
Ensure brevity in your answer.  11. What is the difference between the highest and the second highest Exports(as % of merchandise exports) of Sri Lanka?
Offer a terse response. 0.18. What is the difference between the highest and the second highest Exports(as % of merchandise exports) in Sweden?
Your answer should be very brief. 0.63. What is the difference between the highest and the second highest Exports(as % of merchandise exports) of Venezuela?
Make the answer very short. 4.62. What is the difference between the highest and the lowest Exports(as % of merchandise exports) in Bhutan?
Your response must be concise. 19.88. What is the difference between the highest and the lowest Exports(as % of merchandise exports) of Sri Lanka?
Offer a terse response. 0.22. What is the difference between the highest and the lowest Exports(as % of merchandise exports) of Sweden?
Offer a terse response. 3.33. What is the difference between the highest and the lowest Exports(as % of merchandise exports) in Venezuela?
Your response must be concise. 15.37. 